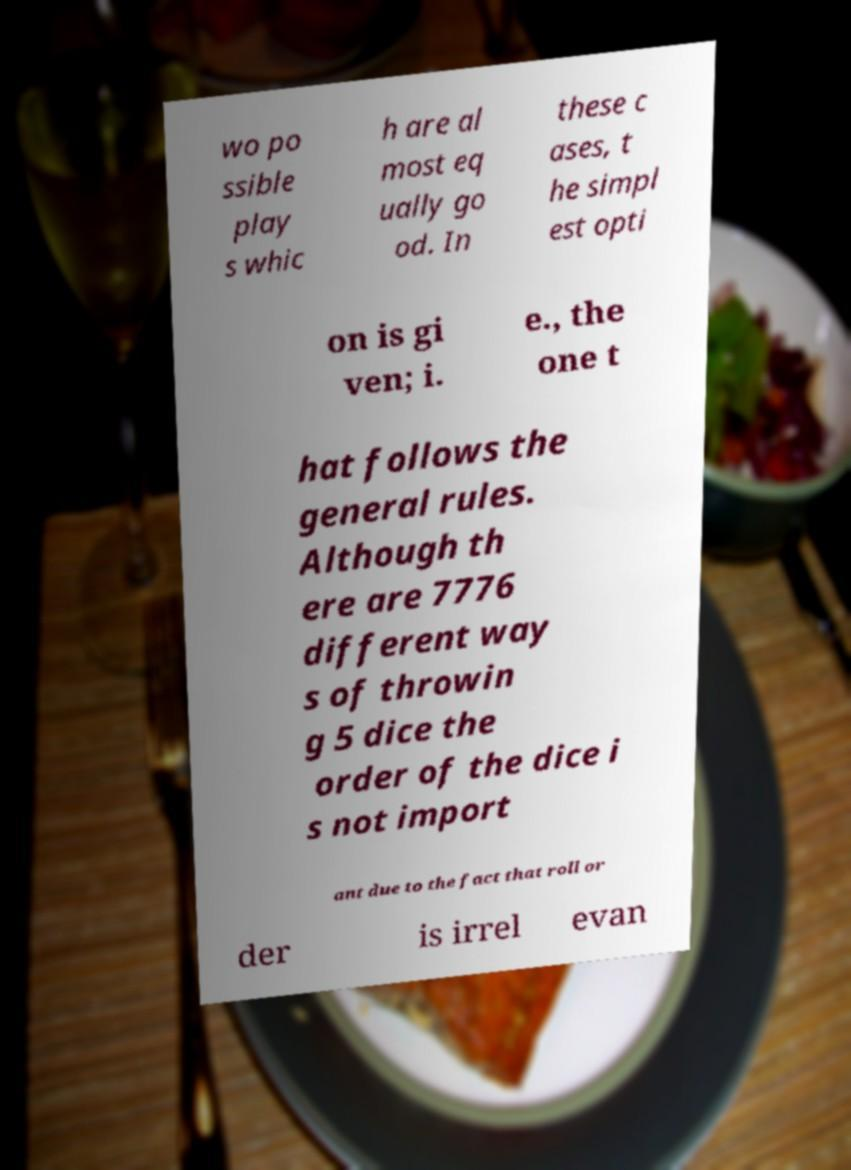Please identify and transcribe the text found in this image. wo po ssible play s whic h are al most eq ually go od. In these c ases, t he simpl est opti on is gi ven; i. e., the one t hat follows the general rules. Although th ere are 7776 different way s of throwin g 5 dice the order of the dice i s not import ant due to the fact that roll or der is irrel evan 